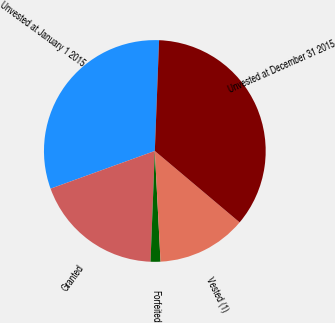<chart> <loc_0><loc_0><loc_500><loc_500><pie_chart><fcel>Unvested at January 1 2015<fcel>Granted<fcel>Forfeited<fcel>Vested (1)<fcel>Unvested at December 31 2015<nl><fcel>31.14%<fcel>18.86%<fcel>1.44%<fcel>13.04%<fcel>35.53%<nl></chart> 